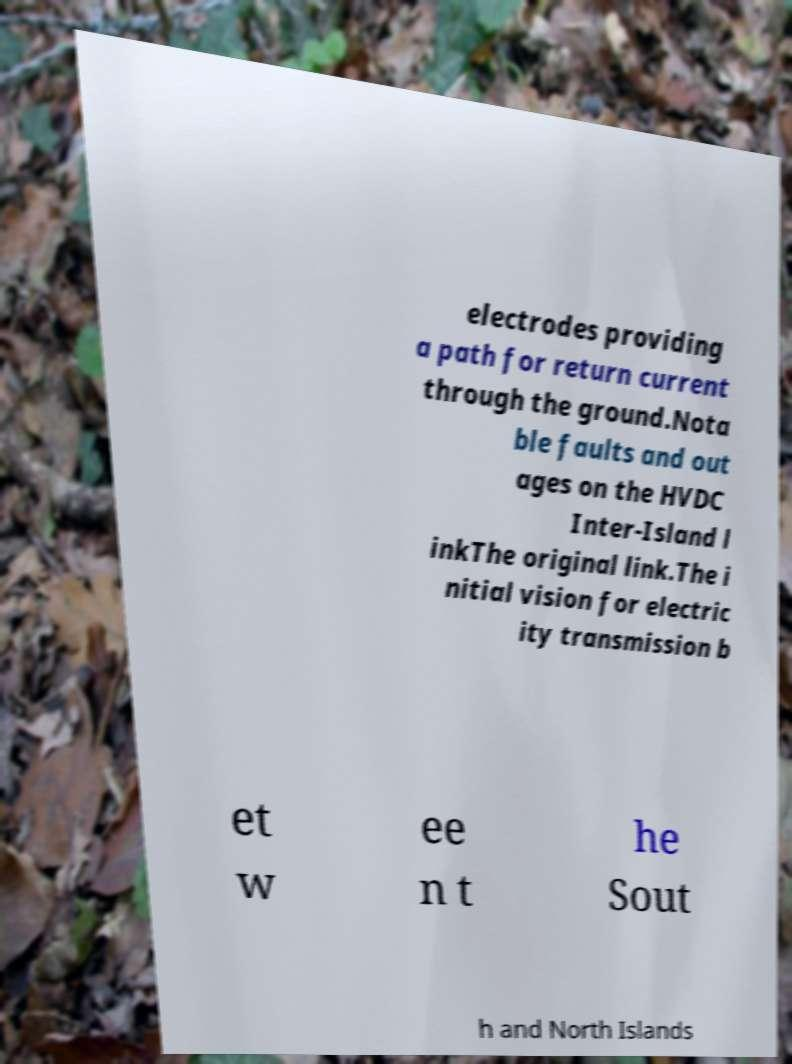Please identify and transcribe the text found in this image. electrodes providing a path for return current through the ground.Nota ble faults and out ages on the HVDC Inter-Island l inkThe original link.The i nitial vision for electric ity transmission b et w ee n t he Sout h and North Islands 